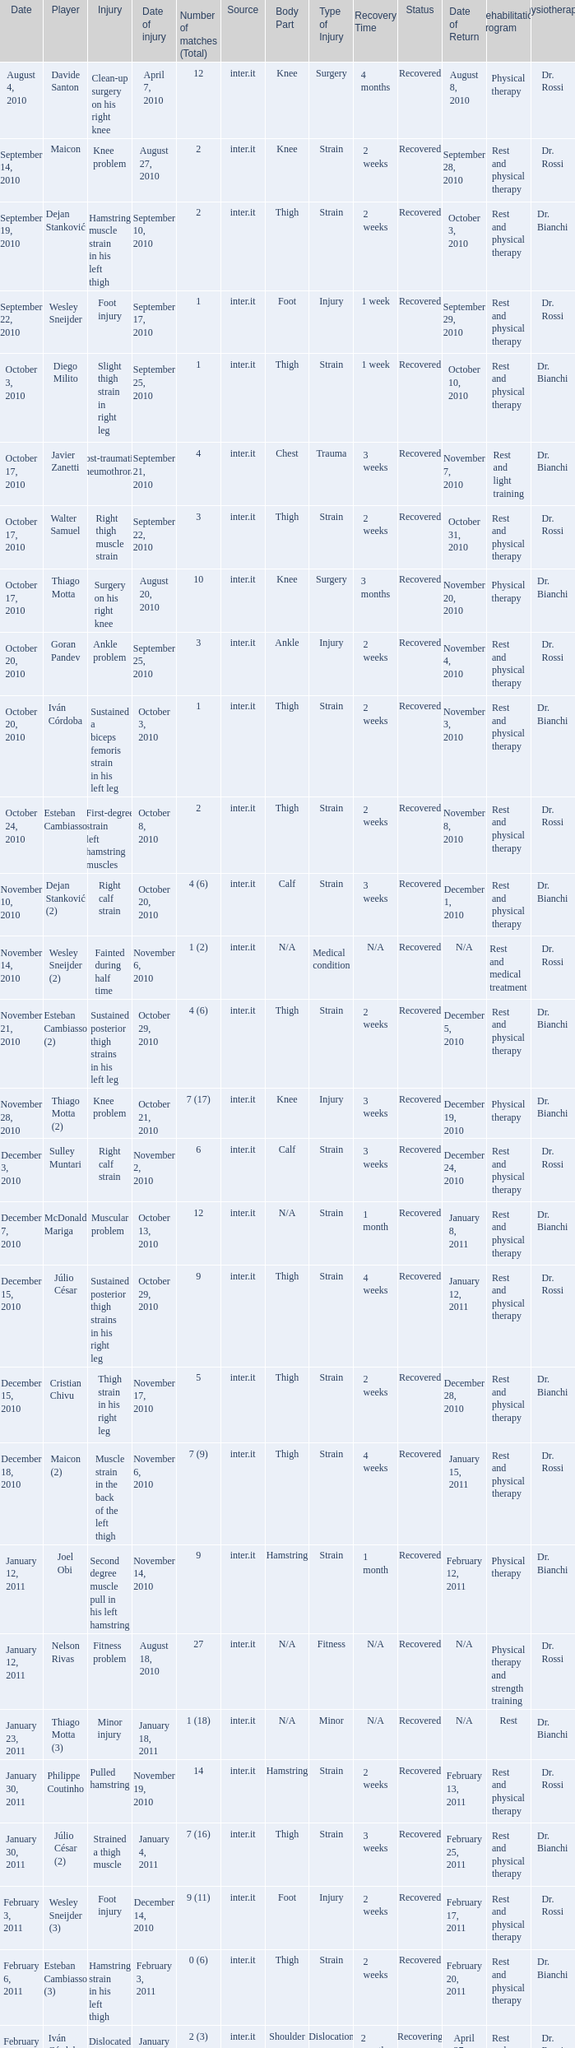What is the date of injury for player Wesley sneijder (2)? November 6, 2010. 